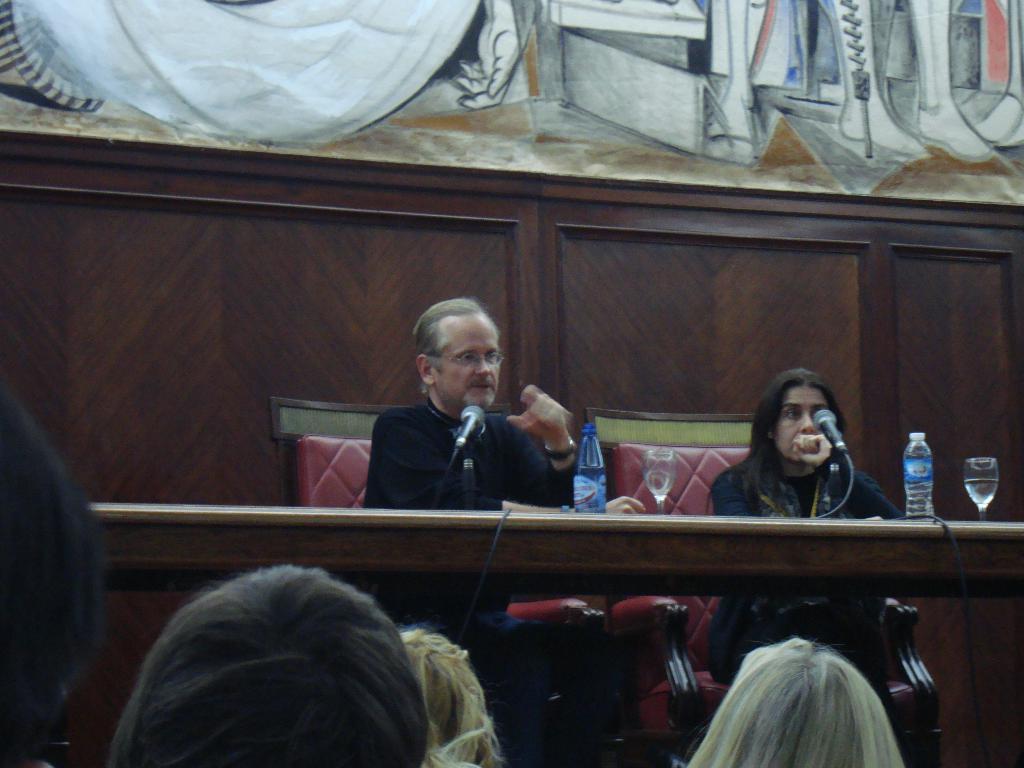Please provide a concise description of this image. In the center of the image there are two people sitting on the chairs. In front of them there is a table and on top of it there are bottles, glasses and mike's. In front of the image there are few people. In the background of the image there is a wall with the painting on it. 